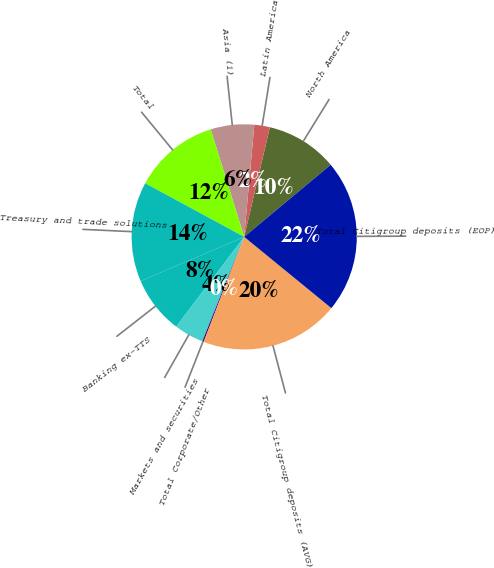Convert chart. <chart><loc_0><loc_0><loc_500><loc_500><pie_chart><fcel>North America<fcel>Latin America<fcel>Asia (1)<fcel>Total<fcel>Treasury and trade solutions<fcel>Banking ex-TTS<fcel>Markets and securities<fcel>Total Corporate/Other<fcel>Total Citigroup deposits (AVG)<fcel>Total Citigroup deposits (EOP)<nl><fcel>10.28%<fcel>2.23%<fcel>6.25%<fcel>12.29%<fcel>14.31%<fcel>8.27%<fcel>4.24%<fcel>0.21%<fcel>19.95%<fcel>21.96%<nl></chart> 